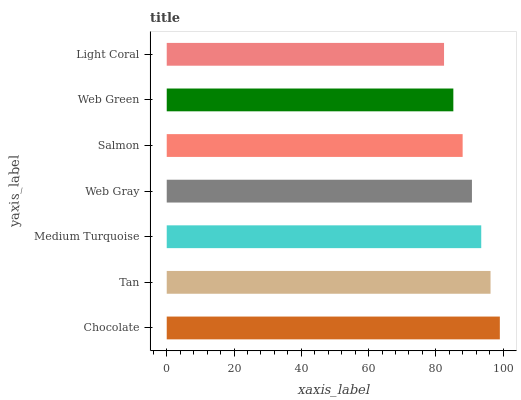Is Light Coral the minimum?
Answer yes or no. Yes. Is Chocolate the maximum?
Answer yes or no. Yes. Is Tan the minimum?
Answer yes or no. No. Is Tan the maximum?
Answer yes or no. No. Is Chocolate greater than Tan?
Answer yes or no. Yes. Is Tan less than Chocolate?
Answer yes or no. Yes. Is Tan greater than Chocolate?
Answer yes or no. No. Is Chocolate less than Tan?
Answer yes or no. No. Is Web Gray the high median?
Answer yes or no. Yes. Is Web Gray the low median?
Answer yes or no. Yes. Is Salmon the high median?
Answer yes or no. No. Is Web Green the low median?
Answer yes or no. No. 